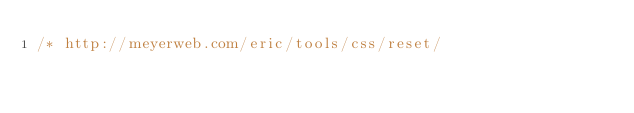<code> <loc_0><loc_0><loc_500><loc_500><_CSS_>/* http://meyerweb.com/eric/tools/css/reset/ </code> 